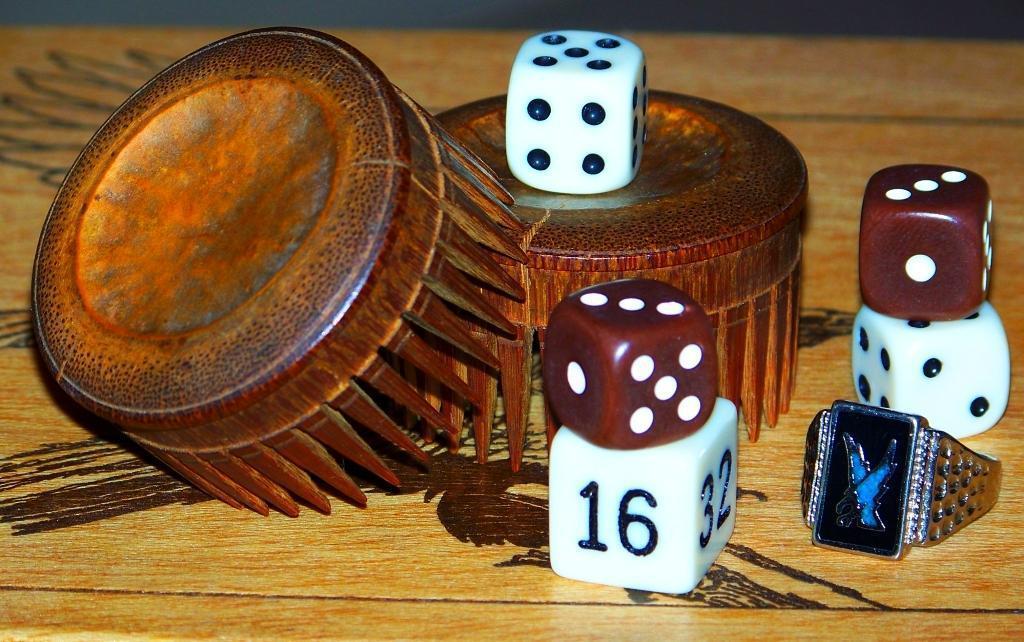Please provide a concise description of this image. In this image we can see a wooden surface, on that there are two wooden objects, dice and a ring. 